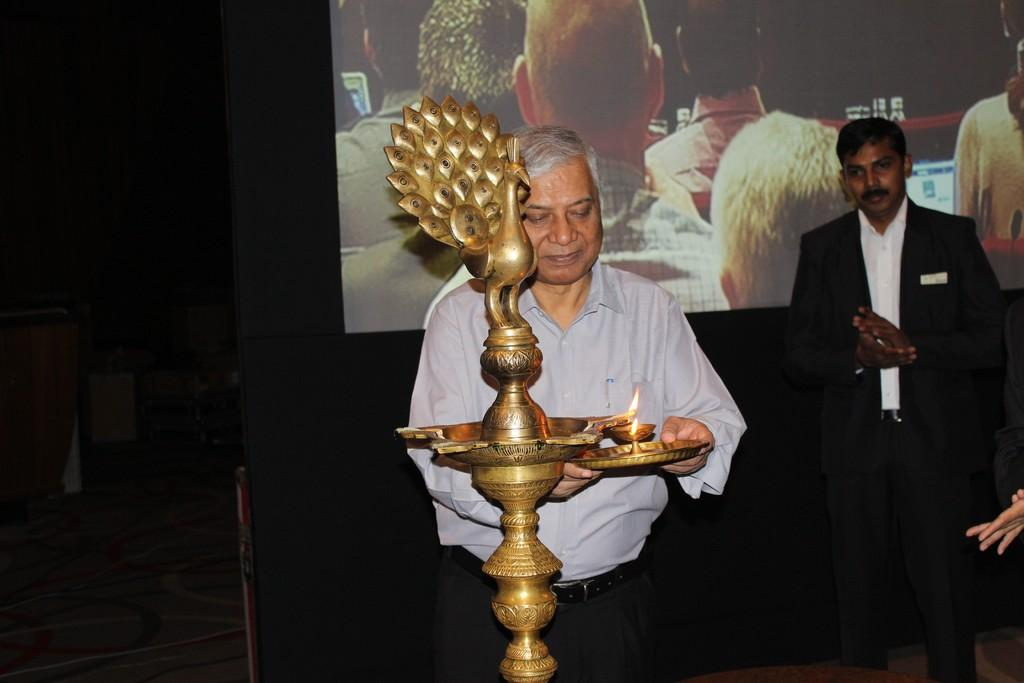How many people are in the image? There are people in the image, but the exact number is not specified. Can you describe the man in the center of the image? The man in the center of the image is standing and holding a plate. What other objects can be seen in the image? There is a lamp and a screen in the background of the image. What type of cherry is the man holding on the plate? The man is not holding a cherry on the plate; he is holding a plate without any specific food item mentioned. How many buns are visible on the screen in the background? There is no mention of buns or a screen displaying buns in the image. 